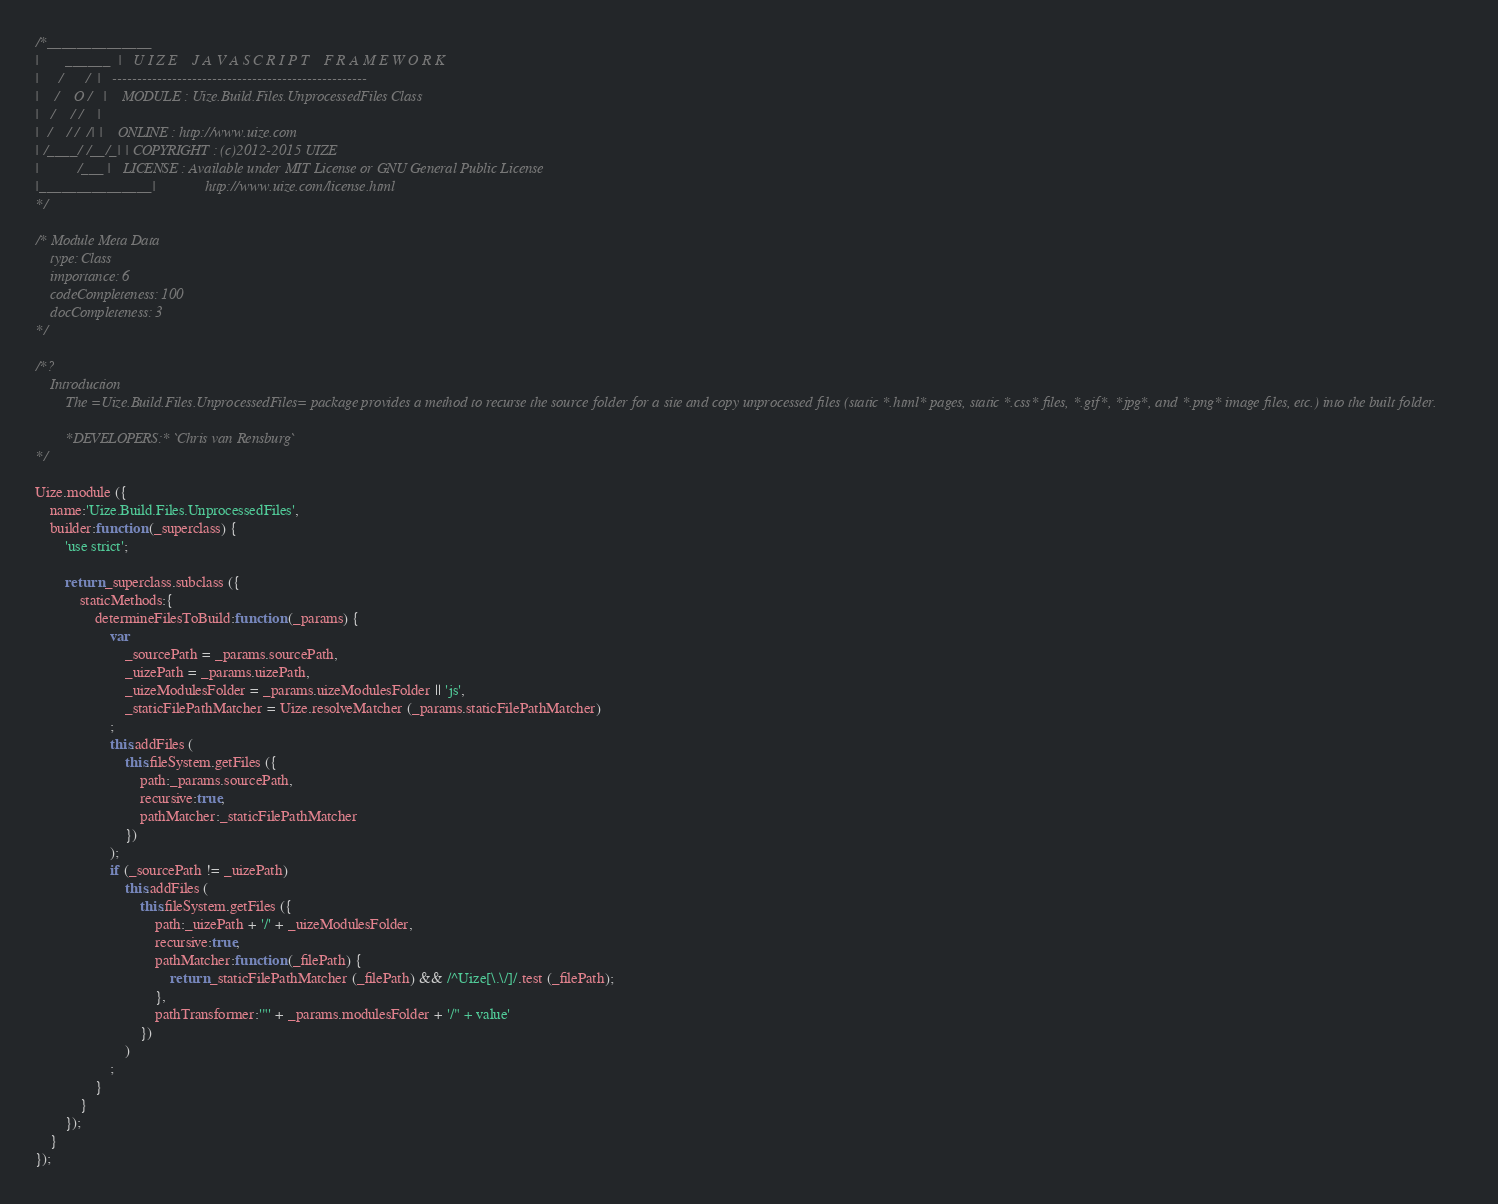Convert code to text. <code><loc_0><loc_0><loc_500><loc_500><_JavaScript_>/*______________
|       ______  |   U I Z E    J A V A S C R I P T    F R A M E W O R K
|     /      /  |   ---------------------------------------------------
|    /    O /   |    MODULE : Uize.Build.Files.UnprocessedFiles Class
|   /    / /    |
|  /    / /  /| |    ONLINE : http://www.uize.com
| /____/ /__/_| | COPYRIGHT : (c)2012-2015 UIZE
|          /___ |   LICENSE : Available under MIT License or GNU General Public License
|_______________|             http://www.uize.com/license.html
*/

/* Module Meta Data
	type: Class
	importance: 6
	codeCompleteness: 100
	docCompleteness: 3
*/

/*?
	Introduction
		The =Uize.Build.Files.UnprocessedFiles= package provides a method to recurse the source folder for a site and copy unprocessed files (static *.html* pages, static *.css* files, *.gif*, *jpg*, and *.png* image files, etc.) into the built folder.

		*DEVELOPERS:* `Chris van Rensburg`
*/

Uize.module ({
	name:'Uize.Build.Files.UnprocessedFiles',
	builder:function (_superclass) {
		'use strict';

		return _superclass.subclass ({
			staticMethods:{
				determineFilesToBuild:function (_params) {
					var
						_sourcePath = _params.sourcePath,
						_uizePath = _params.uizePath,
						_uizeModulesFolder = _params.uizeModulesFolder || 'js',
						_staticFilePathMatcher = Uize.resolveMatcher (_params.staticFilePathMatcher)
					;
					this.addFiles (
						this.fileSystem.getFiles ({
							path:_params.sourcePath,
							recursive:true,
							pathMatcher:_staticFilePathMatcher
						})
					);
					if (_sourcePath != _uizePath)
						this.addFiles (
							this.fileSystem.getFiles ({
								path:_uizePath + '/' + _uizeModulesFolder,
								recursive:true,
								pathMatcher:function (_filePath) {
									return _staticFilePathMatcher (_filePath) && /^Uize[\.\/]/.test (_filePath);
								},
								pathTransformer:'"' + _params.modulesFolder + '/" + value'
							})
						)
					;
				}
			}
		});
	}
});

</code> 